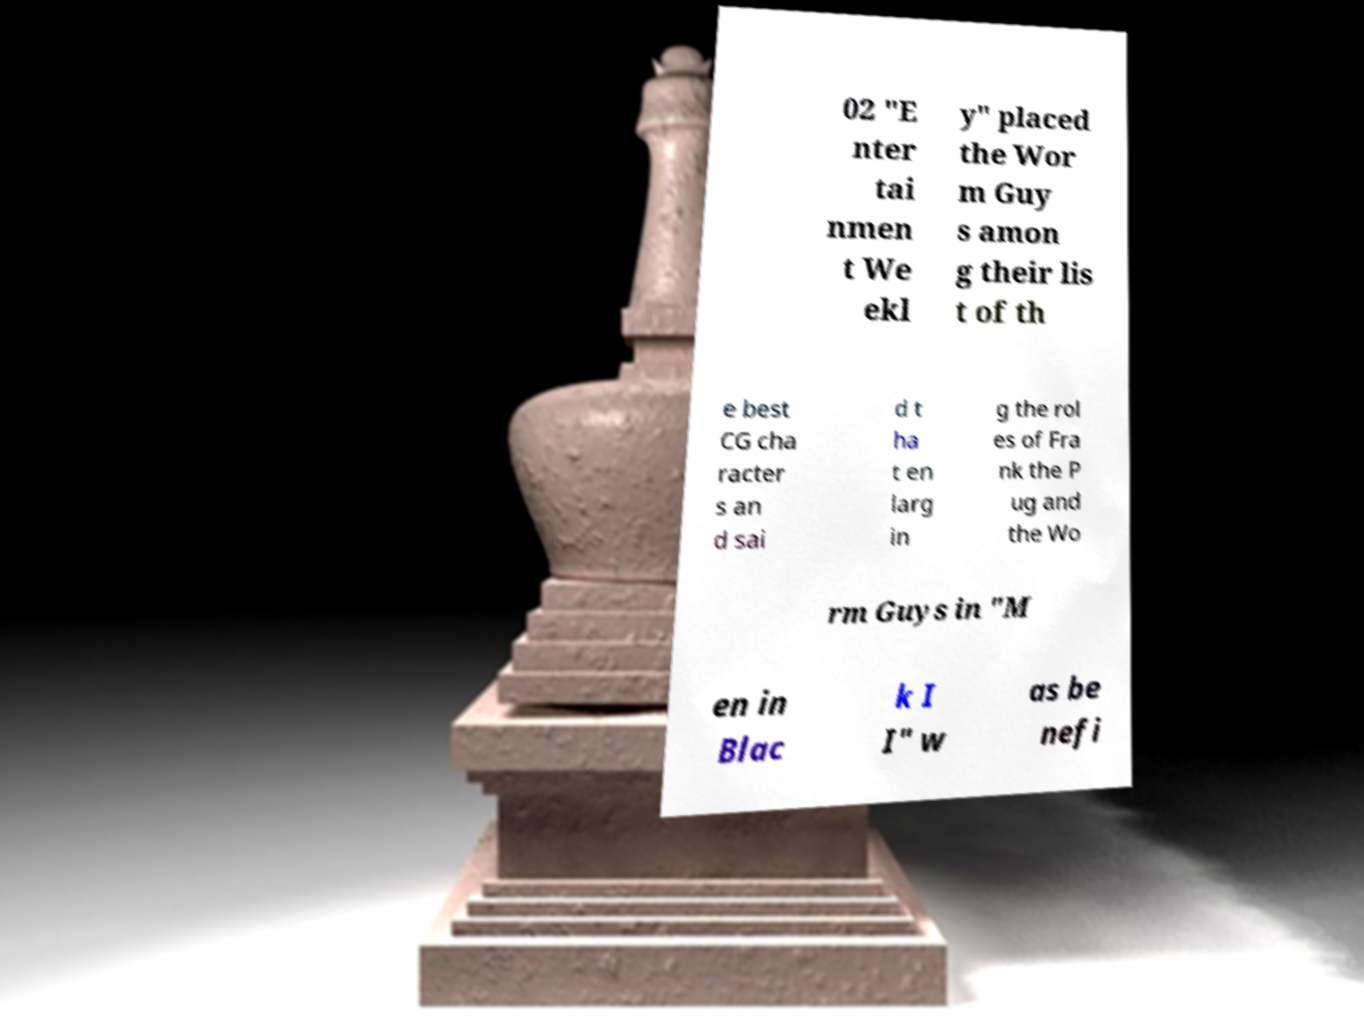Can you read and provide the text displayed in the image?This photo seems to have some interesting text. Can you extract and type it out for me? 02 "E nter tai nmen t We ekl y" placed the Wor m Guy s amon g their lis t of th e best CG cha racter s an d sai d t ha t en larg in g the rol es of Fra nk the P ug and the Wo rm Guys in "M en in Blac k I I" w as be nefi 